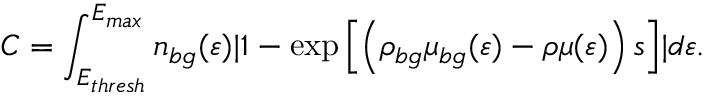Convert formula to latex. <formula><loc_0><loc_0><loc_500><loc_500>C = \int _ { E _ { t h r e s h } } ^ { E _ { \max } } n _ { b g } ( \varepsilon ) | 1 - \exp \left [ \left ( \rho _ { b g } \mu _ { b g } ( \varepsilon ) - \rho \mu ( \varepsilon ) \right ) s \right ] | d \varepsilon .</formula> 